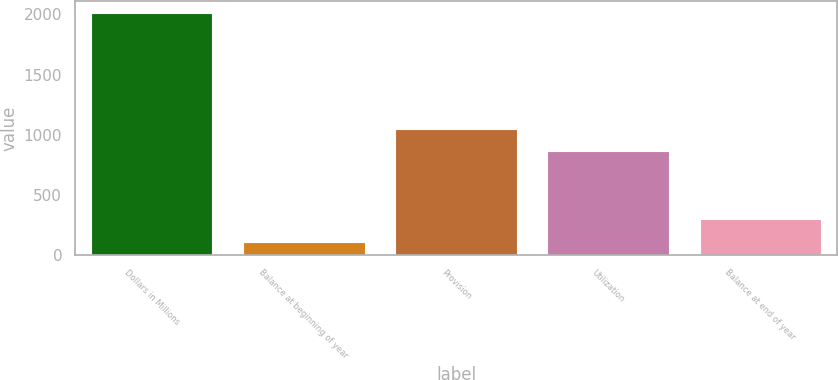Convert chart. <chart><loc_0><loc_0><loc_500><loc_500><bar_chart><fcel>Dollars in Millions<fcel>Balance at beginning of year<fcel>Provision<fcel>Utilization<fcel>Balance at end of year<nl><fcel>2010<fcel>103<fcel>1050.7<fcel>860<fcel>293.7<nl></chart> 